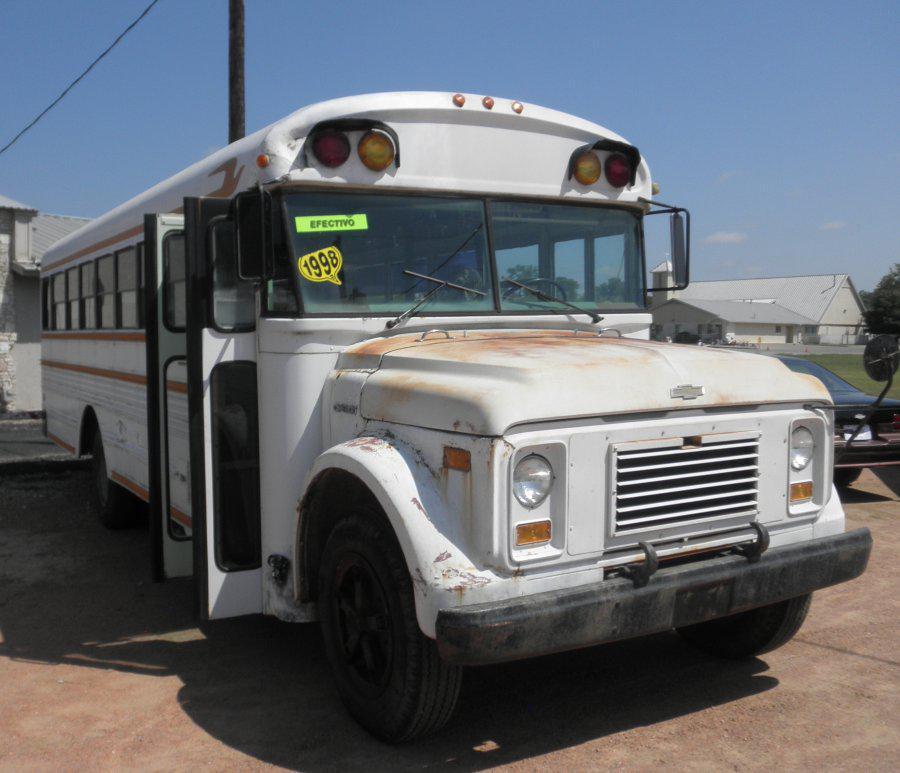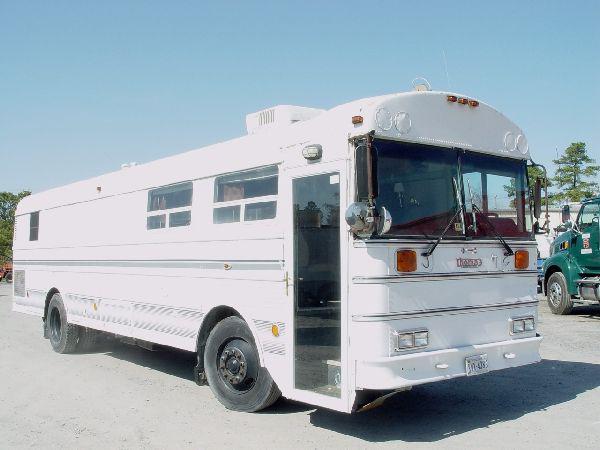The first image is the image on the left, the second image is the image on the right. Assess this claim about the two images: "In at least one image there is a white bus with a flat front hood facing forward right.". Correct or not? Answer yes or no. Yes. 